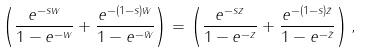<formula> <loc_0><loc_0><loc_500><loc_500>\left ( \frac { e ^ { - s w } } { 1 - e ^ { - w } } + \frac { e ^ { - ( 1 - s ) \bar { w } } } { 1 - e ^ { - \bar { w } } } \right ) = \left ( \frac { e ^ { - s z } } { 1 - e ^ { - z } } + \frac { e ^ { - ( 1 - s ) \bar { z } } } { 1 - e ^ { - \bar { z } } } \right ) ,</formula> 